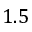Convert formula to latex. <formula><loc_0><loc_0><loc_500><loc_500>1 . 5</formula> 